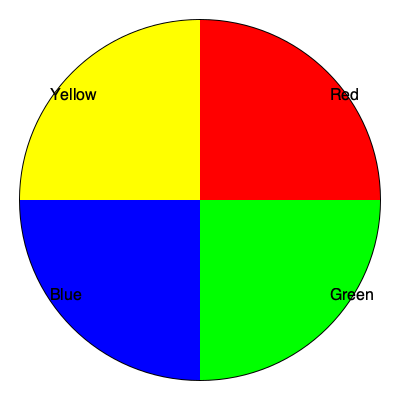Based on the color wheel provided, which color would be the most harmonious complement to create an elegant contrast with a pale blue wedding theme? To determine the most harmonious complement for a pale blue wedding theme, we need to follow these steps:

1. Identify the base color: In this case, it's pale blue, which is a lighter shade of blue.

2. Locate blue on the color wheel: Blue is one of the primary colors and is shown in the bottom-left quadrant of the provided color wheel.

3. Find the complementary color: Complementary colors are directly opposite each other on the color wheel. The color directly opposite blue is yellow, which is in the top-left quadrant.

4. Consider the pale nature of the blue: Since the theme is pale blue, we should consider a softer version of its complement to maintain elegance and avoid overwhelming contrast.

5. Adjust the complement: A pale yellow or soft golden hue would be the most harmonious complement to pale blue, creating an elegant contrast while maintaining a cohesive and sophisticated color scheme.

This color combination follows the principle of complementary colors in color theory, which states that colors opposite each other on the color wheel create maximum contrast and stability.
Answer: Pale yellow or soft gold 